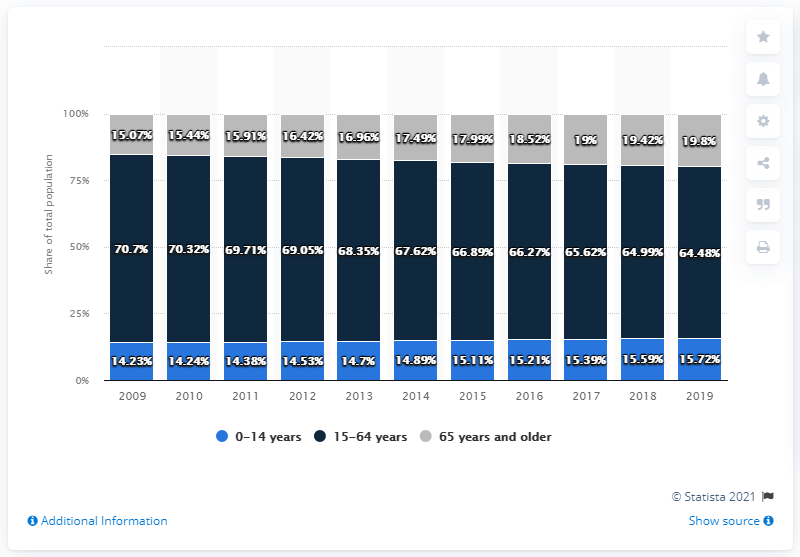Mention a couple of crucial points in this snapshot. In 2015, the percentage share of the 15-64 age group in the total population was 66.89%. From 2015 to 2016, the 15-64 years group comprised an average of 66.58% of the total population. 